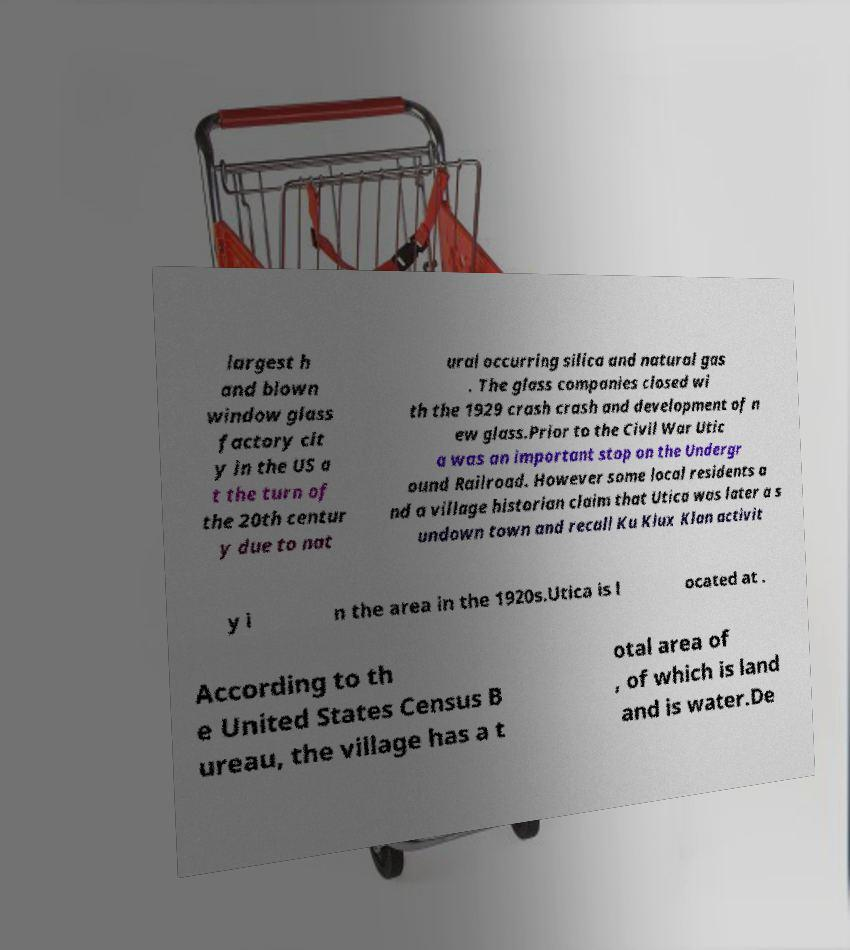Can you read and provide the text displayed in the image?This photo seems to have some interesting text. Can you extract and type it out for me? largest h and blown window glass factory cit y in the US a t the turn of the 20th centur y due to nat ural occurring silica and natural gas . The glass companies closed wi th the 1929 crash crash and development of n ew glass.Prior to the Civil War Utic a was an important stop on the Undergr ound Railroad. However some local residents a nd a village historian claim that Utica was later a s undown town and recall Ku Klux Klan activit y i n the area in the 1920s.Utica is l ocated at . According to th e United States Census B ureau, the village has a t otal area of , of which is land and is water.De 